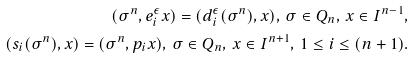<formula> <loc_0><loc_0><loc_500><loc_500>( \sigma ^ { n } , e _ { i } ^ { \epsilon } x ) = ( d _ { i } ^ { \epsilon } ( \sigma ^ { n } ) , x ) , \, \sigma \in Q _ { n } , \, x \in I ^ { n - 1 } , \\ ( s _ { i } ( \sigma ^ { n } ) , x ) = ( \sigma ^ { n } , p _ { i } x ) , \, \sigma \in Q _ { n } , \, x \in I ^ { n + 1 } , \, 1 \leq i \leq ( n + 1 ) .</formula> 